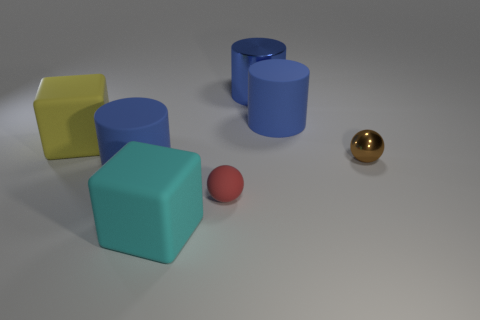There is a cube that is left of the large cyan rubber cube; how many brown metallic things are in front of it?
Offer a very short reply. 1. How big is the blue cylinder that is both in front of the blue shiny thing and behind the large yellow rubber block?
Offer a very short reply. Large. Do the big yellow block and the small ball that is behind the small red object have the same material?
Offer a very short reply. No. Are there fewer big blue shiny objects that are right of the big blue metal thing than big blue cylinders behind the small brown ball?
Provide a short and direct response. Yes. What material is the big cylinder that is in front of the tiny metal sphere?
Your response must be concise. Rubber. What color is the big matte object that is both behind the small brown sphere and to the left of the blue metal cylinder?
Provide a short and direct response. Yellow. How many other things are there of the same color as the tiny matte ball?
Provide a short and direct response. 0. What is the color of the cylinder on the left side of the large cyan matte block?
Give a very brief answer. Blue. Are there any metallic cylinders of the same size as the brown metal ball?
Your answer should be very brief. No. There is a red sphere that is the same size as the brown sphere; what is it made of?
Provide a short and direct response. Rubber. 